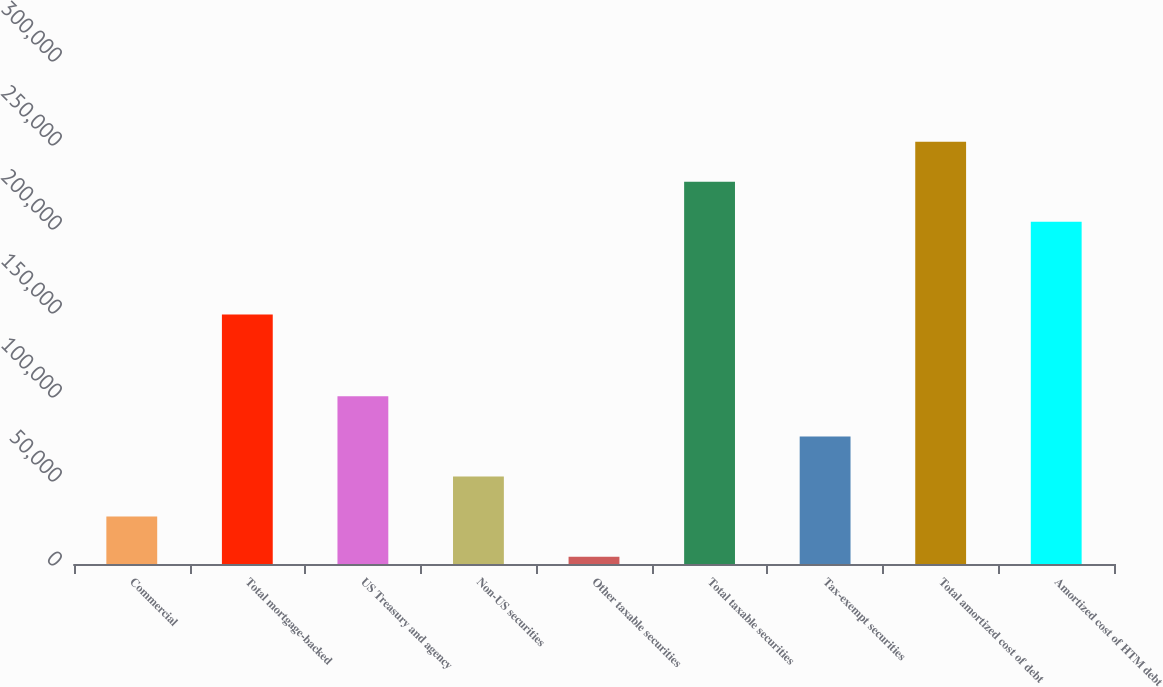Convert chart to OTSL. <chart><loc_0><loc_0><loc_500><loc_500><bar_chart><fcel>Commercial<fcel>Total mortgage-backed<fcel>US Treasury and agency<fcel>Non-US securities<fcel>Other taxable securities<fcel>Total taxable securities<fcel>Tax-exempt securities<fcel>Total amortized cost of debt<fcel>Amortized cost of HTM debt<nl><fcel>28235.8<fcel>148488<fcel>99782.2<fcel>52084.6<fcel>4387<fcel>227501<fcel>75933.4<fcel>251350<fcel>203652<nl></chart> 